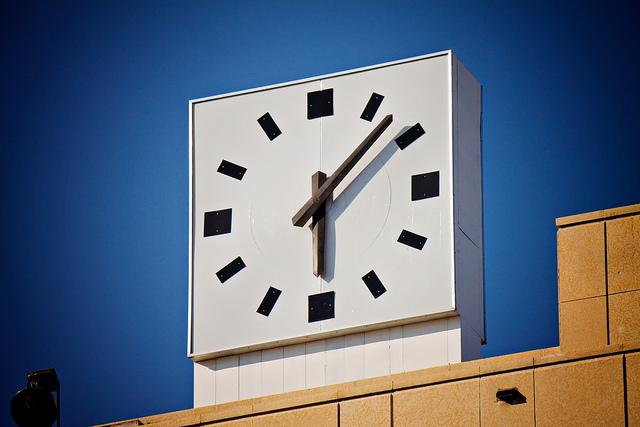Does the clock have actual numbers on its face?
Be succinct. No. Are those roman numerals?
Short answer required. No. Does the clock work?
Give a very brief answer. Yes. 